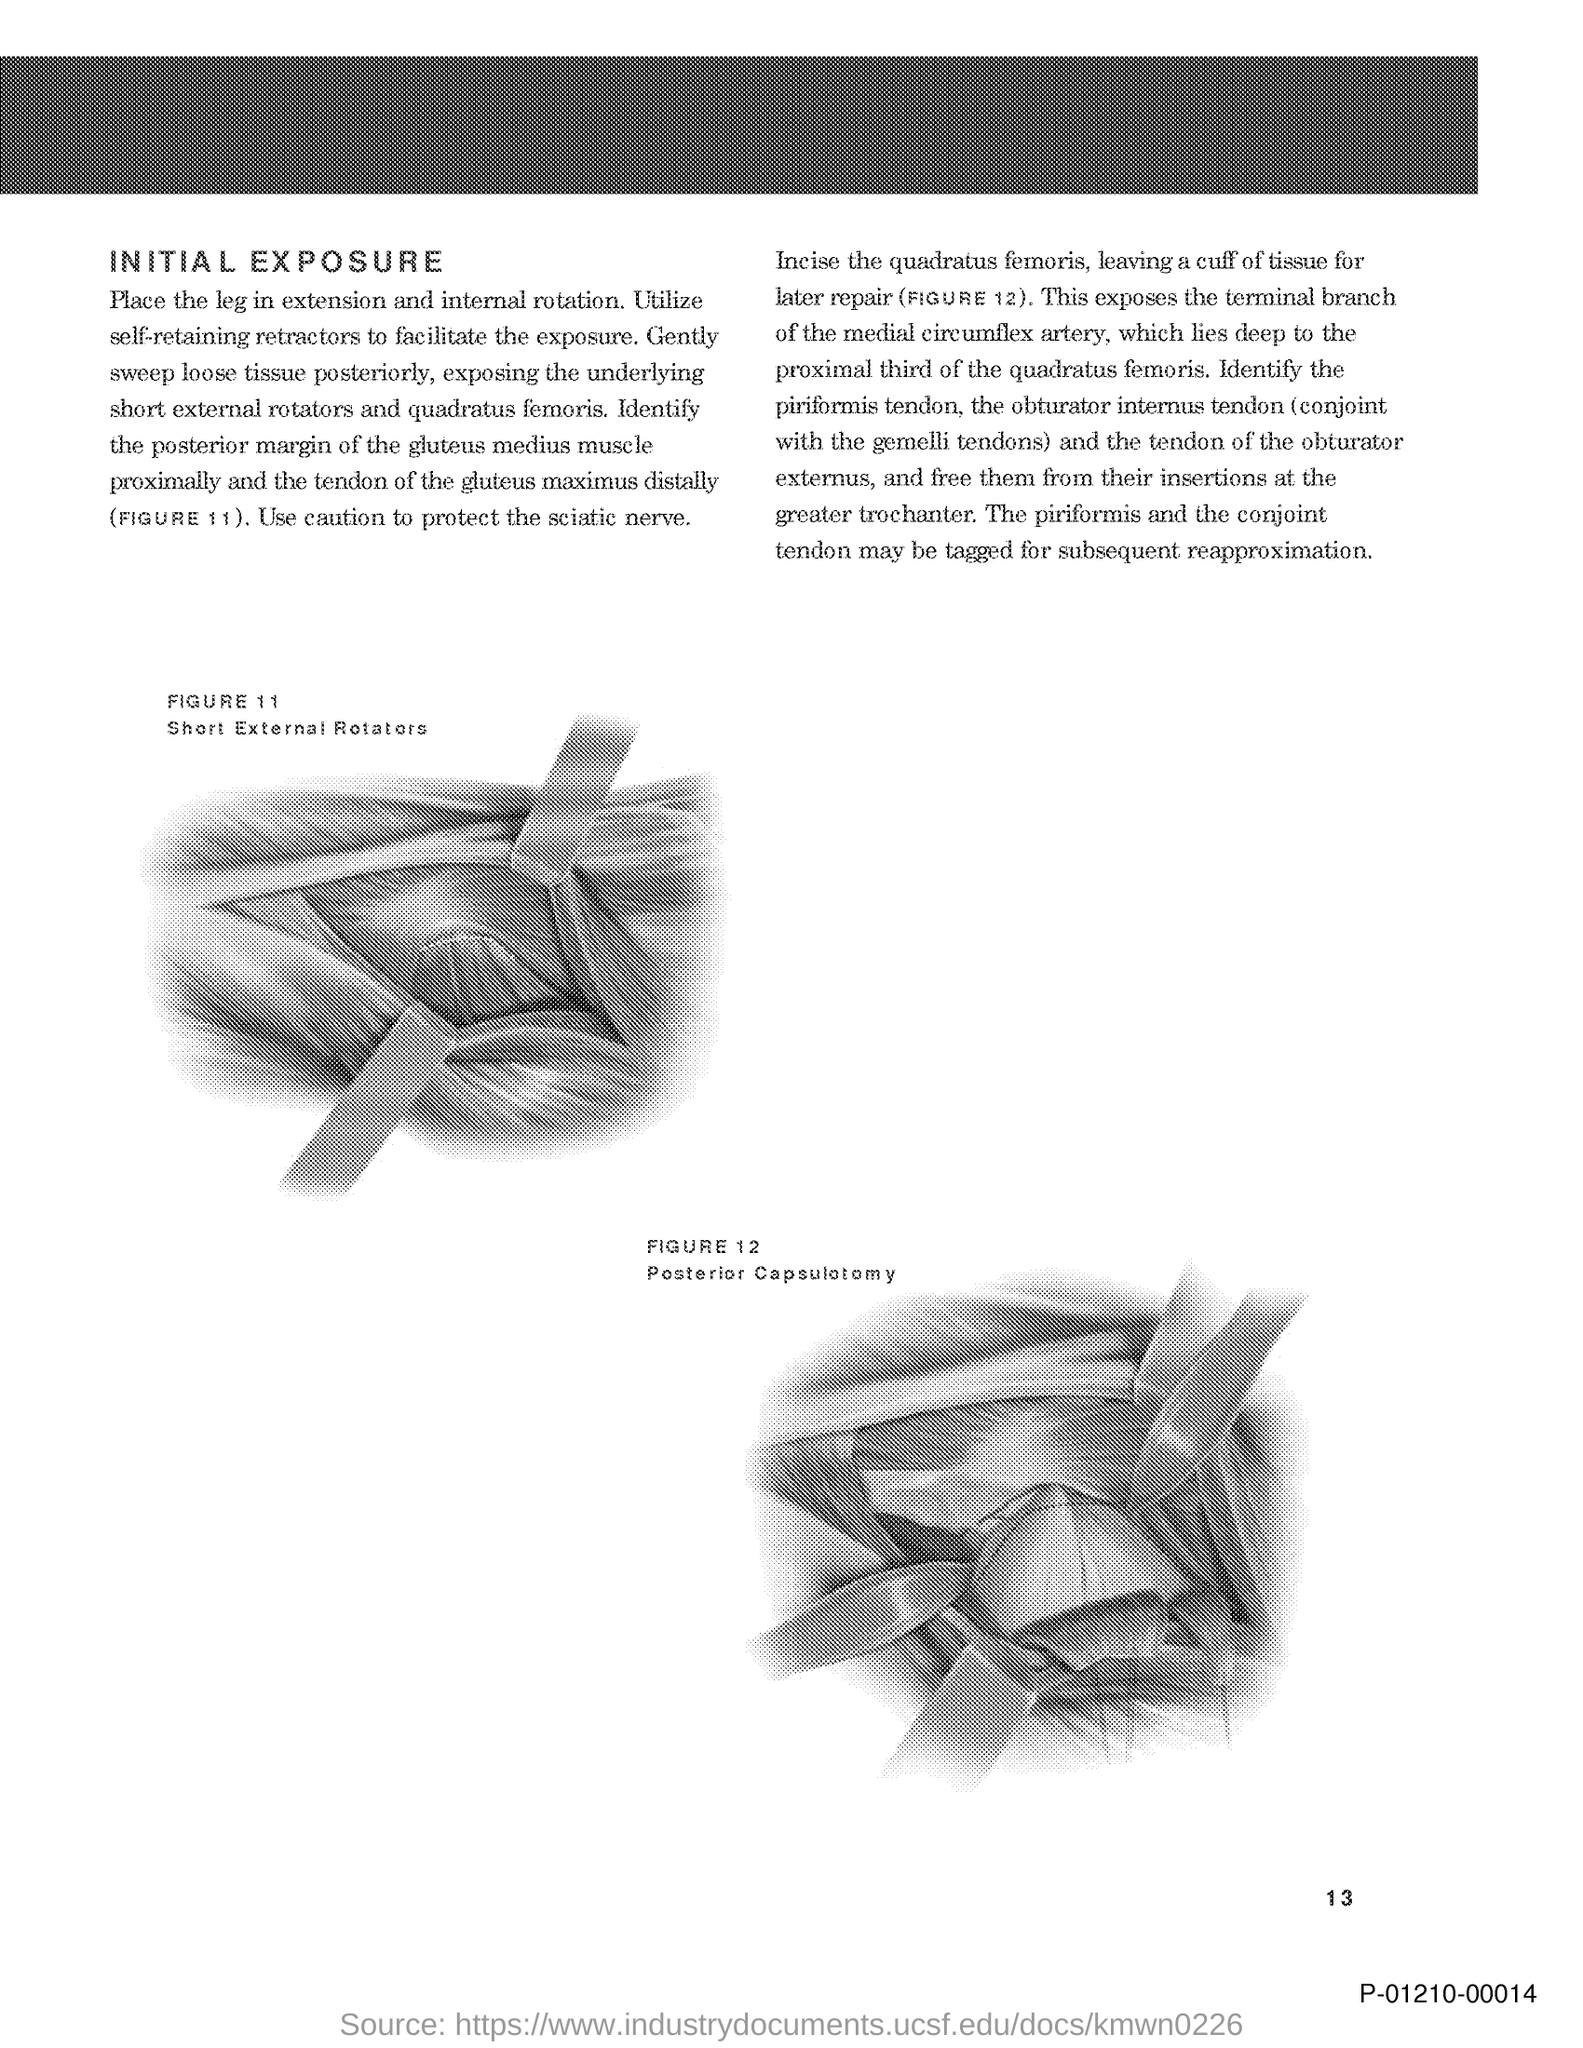Mention a couple of crucial points in this snapshot. The initial title in the document is 'Initial Exposure.' 